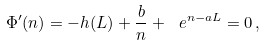<formula> <loc_0><loc_0><loc_500><loc_500>\Phi ^ { \prime } ( n ) = - h ( L ) + \frac { b } { n } + \ e ^ { n - a L } = 0 \, ,</formula> 